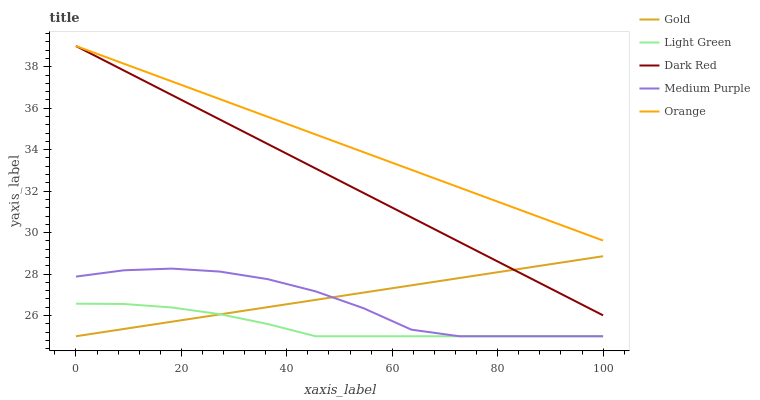Does Light Green have the minimum area under the curve?
Answer yes or no. Yes. Does Orange have the maximum area under the curve?
Answer yes or no. Yes. Does Dark Red have the minimum area under the curve?
Answer yes or no. No. Does Dark Red have the maximum area under the curve?
Answer yes or no. No. Is Dark Red the smoothest?
Answer yes or no. Yes. Is Medium Purple the roughest?
Answer yes or no. Yes. Is Orange the smoothest?
Answer yes or no. No. Is Orange the roughest?
Answer yes or no. No. Does Medium Purple have the lowest value?
Answer yes or no. Yes. Does Dark Red have the lowest value?
Answer yes or no. No. Does Orange have the highest value?
Answer yes or no. Yes. Does Light Green have the highest value?
Answer yes or no. No. Is Light Green less than Dark Red?
Answer yes or no. Yes. Is Orange greater than Medium Purple?
Answer yes or no. Yes. Does Gold intersect Dark Red?
Answer yes or no. Yes. Is Gold less than Dark Red?
Answer yes or no. No. Is Gold greater than Dark Red?
Answer yes or no. No. Does Light Green intersect Dark Red?
Answer yes or no. No. 